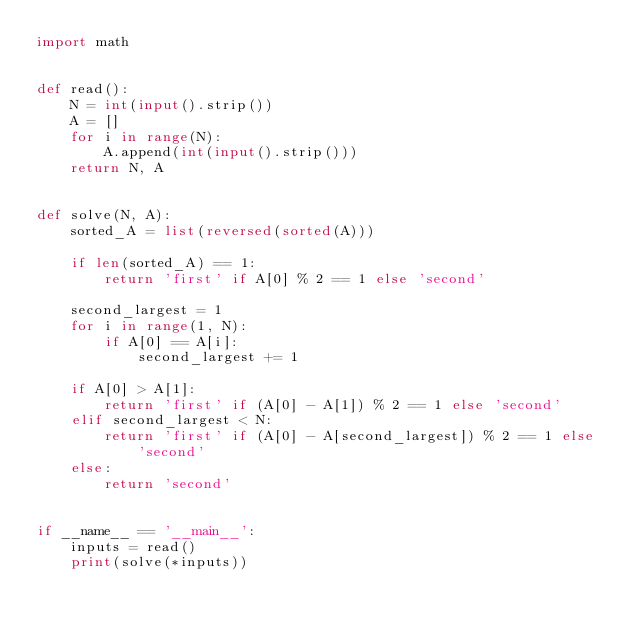Convert code to text. <code><loc_0><loc_0><loc_500><loc_500><_Python_>import math


def read():
    N = int(input().strip())
    A = []
    for i in range(N):
        A.append(int(input().strip()))
    return N, A


def solve(N, A):
    sorted_A = list(reversed(sorted(A)))

    if len(sorted_A) == 1:
        return 'first' if A[0] % 2 == 1 else 'second'

    second_largest = 1
    for i in range(1, N):
        if A[0] == A[i]:
            second_largest += 1

    if A[0] > A[1]:
        return 'first' if (A[0] - A[1]) % 2 == 1 else 'second'
    elif second_largest < N:
        return 'first' if (A[0] - A[second_largest]) % 2 == 1 else 'second'
    else:
        return 'second'


if __name__ == '__main__':
    inputs = read()
    print(solve(*inputs))
</code> 